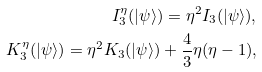<formula> <loc_0><loc_0><loc_500><loc_500>I ^ { \eta } _ { 3 } ( | \psi \rangle ) = \eta ^ { 2 } I _ { 3 } ( | \psi \rangle ) , \\ K ^ { \eta } _ { 3 } ( | \psi \rangle ) = \eta ^ { 2 } K _ { 3 } ( | \psi \rangle ) + \frac { 4 } { 3 } \eta ( \eta - 1 ) ,</formula> 